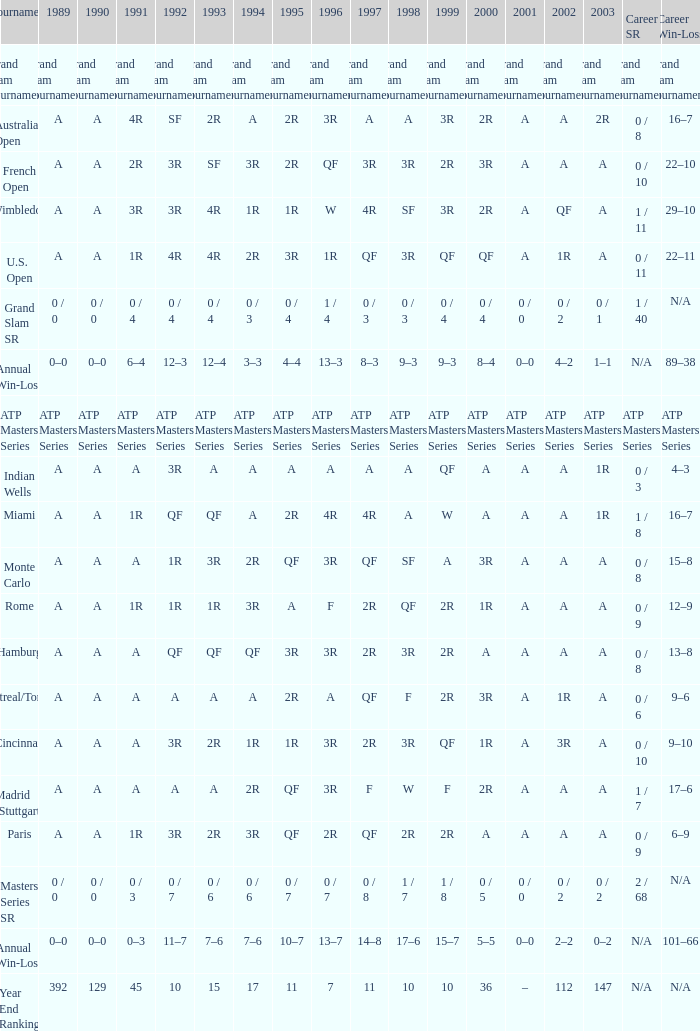What was the worth in 1989 with qf in 1997 and a in 1993? A. 